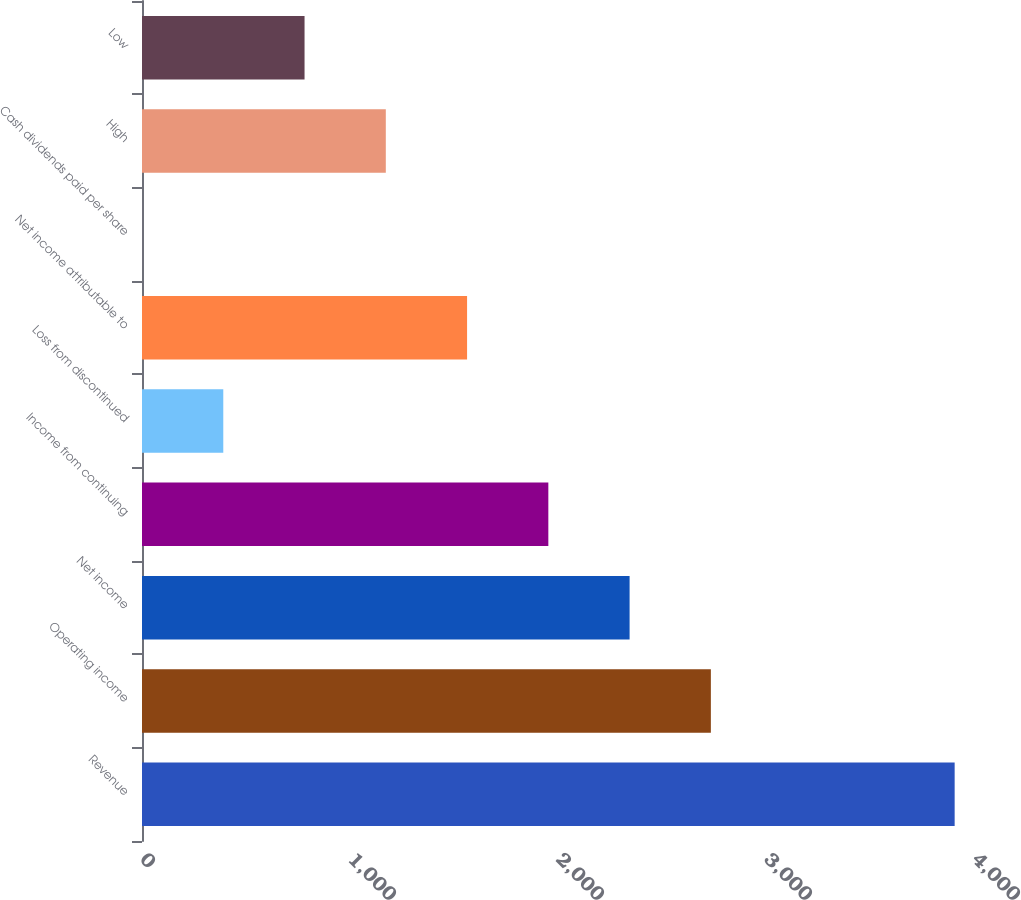Convert chart. <chart><loc_0><loc_0><loc_500><loc_500><bar_chart><fcel>Revenue<fcel>Operating income<fcel>Net income<fcel>Income from continuing<fcel>Loss from discontinued<fcel>Net income attributable to<fcel>Cash dividends paid per share<fcel>High<fcel>Low<nl><fcel>3907<fcel>2734.92<fcel>2344.23<fcel>1953.54<fcel>390.78<fcel>1562.85<fcel>0.09<fcel>1172.16<fcel>781.47<nl></chart> 